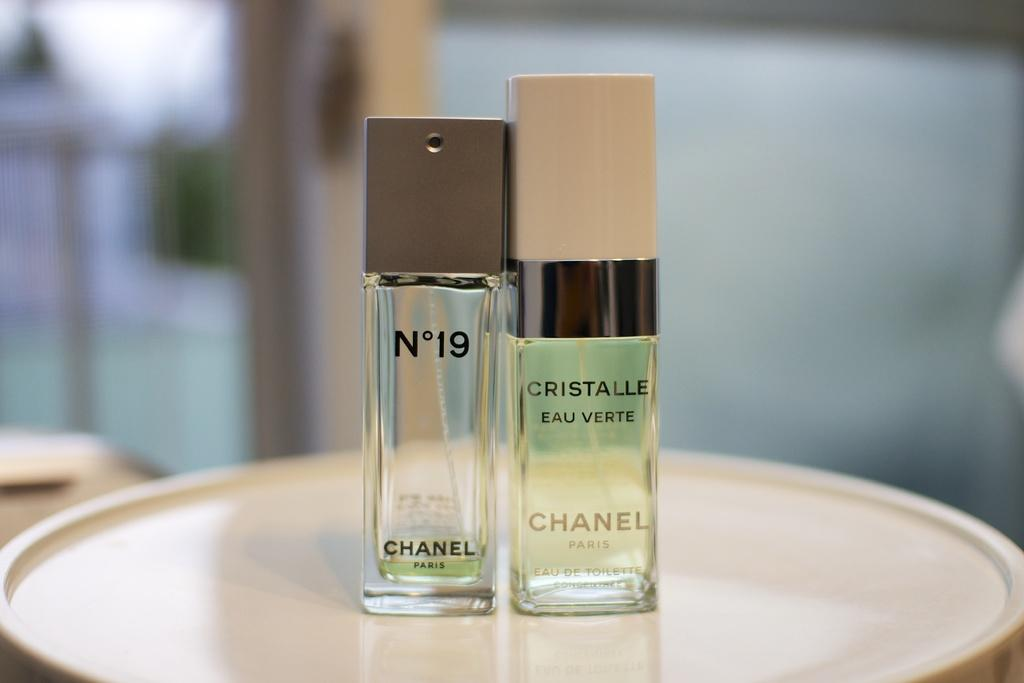<image>
Share a concise interpretation of the image provided. Two bottles of Chanel perfume on a white tray. 